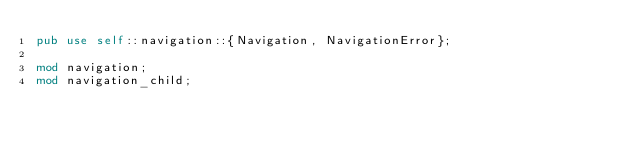<code> <loc_0><loc_0><loc_500><loc_500><_Rust_>pub use self::navigation::{Navigation, NavigationError};

mod navigation;
mod navigation_child;
</code> 